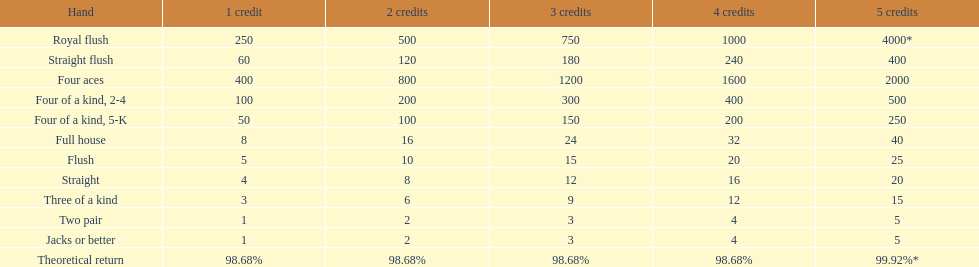What is the total amount of a 3 credit straight flush? 180. 